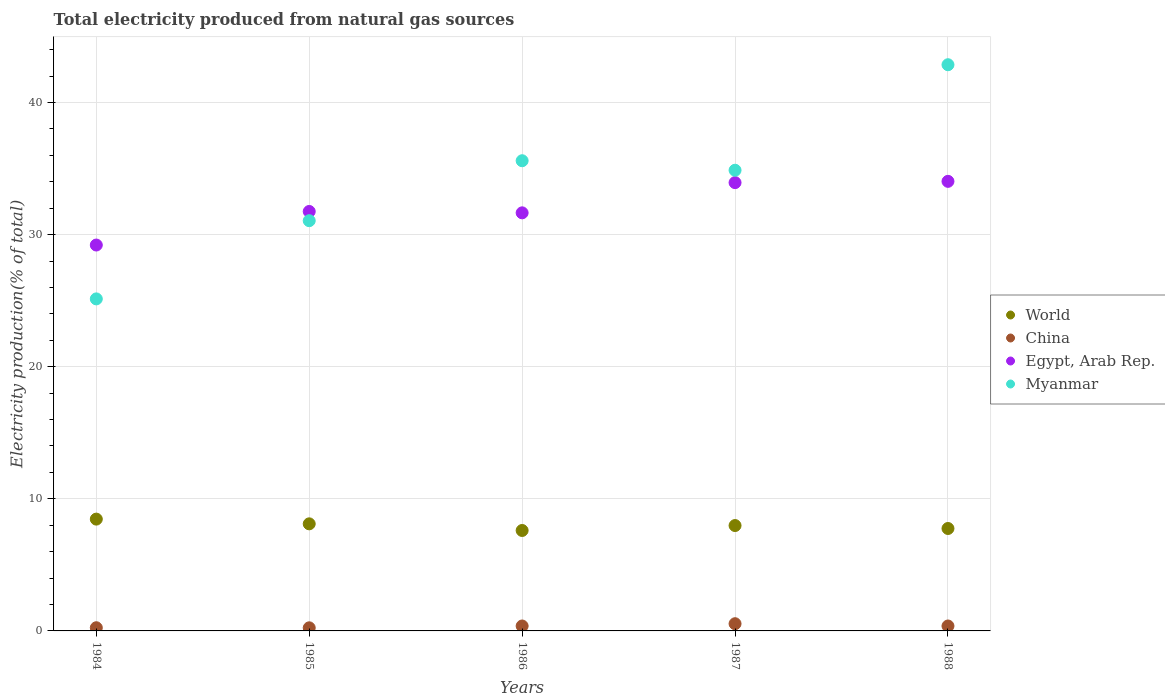How many different coloured dotlines are there?
Provide a succinct answer. 4. Is the number of dotlines equal to the number of legend labels?
Make the answer very short. Yes. What is the total electricity produced in Myanmar in 1986?
Give a very brief answer. 35.59. Across all years, what is the maximum total electricity produced in China?
Provide a succinct answer. 0.55. Across all years, what is the minimum total electricity produced in Myanmar?
Give a very brief answer. 25.13. In which year was the total electricity produced in Egypt, Arab Rep. maximum?
Your answer should be very brief. 1988. In which year was the total electricity produced in China minimum?
Offer a terse response. 1985. What is the total total electricity produced in Myanmar in the graph?
Offer a very short reply. 169.5. What is the difference between the total electricity produced in China in 1984 and that in 1988?
Provide a short and direct response. -0.13. What is the difference between the total electricity produced in Egypt, Arab Rep. in 1985 and the total electricity produced in World in 1987?
Ensure brevity in your answer.  23.77. What is the average total electricity produced in Myanmar per year?
Provide a short and direct response. 33.9. In the year 1985, what is the difference between the total electricity produced in Egypt, Arab Rep. and total electricity produced in China?
Keep it short and to the point. 31.52. What is the ratio of the total electricity produced in China in 1985 to that in 1988?
Give a very brief answer. 0.63. Is the total electricity produced in Myanmar in 1986 less than that in 1987?
Ensure brevity in your answer.  No. Is the difference between the total electricity produced in Egypt, Arab Rep. in 1986 and 1988 greater than the difference between the total electricity produced in China in 1986 and 1988?
Keep it short and to the point. No. What is the difference between the highest and the second highest total electricity produced in World?
Give a very brief answer. 0.36. What is the difference between the highest and the lowest total electricity produced in Myanmar?
Make the answer very short. 17.72. Is it the case that in every year, the sum of the total electricity produced in Myanmar and total electricity produced in World  is greater than the total electricity produced in China?
Your response must be concise. Yes. Is the total electricity produced in World strictly greater than the total electricity produced in China over the years?
Your answer should be compact. Yes. What is the difference between two consecutive major ticks on the Y-axis?
Provide a succinct answer. 10. Are the values on the major ticks of Y-axis written in scientific E-notation?
Your answer should be very brief. No. Does the graph contain grids?
Offer a very short reply. Yes. How many legend labels are there?
Ensure brevity in your answer.  4. What is the title of the graph?
Ensure brevity in your answer.  Total electricity produced from natural gas sources. Does "Central Europe" appear as one of the legend labels in the graph?
Your answer should be very brief. No. What is the label or title of the X-axis?
Ensure brevity in your answer.  Years. What is the Electricity production(% of total) of World in 1984?
Your answer should be compact. 8.46. What is the Electricity production(% of total) of China in 1984?
Keep it short and to the point. 0.24. What is the Electricity production(% of total) of Egypt, Arab Rep. in 1984?
Offer a terse response. 29.21. What is the Electricity production(% of total) in Myanmar in 1984?
Make the answer very short. 25.13. What is the Electricity production(% of total) in World in 1985?
Your answer should be very brief. 8.11. What is the Electricity production(% of total) of China in 1985?
Ensure brevity in your answer.  0.23. What is the Electricity production(% of total) in Egypt, Arab Rep. in 1985?
Give a very brief answer. 31.75. What is the Electricity production(% of total) in Myanmar in 1985?
Offer a very short reply. 31.05. What is the Electricity production(% of total) in World in 1986?
Give a very brief answer. 7.6. What is the Electricity production(% of total) of China in 1986?
Your answer should be compact. 0.37. What is the Electricity production(% of total) in Egypt, Arab Rep. in 1986?
Make the answer very short. 31.65. What is the Electricity production(% of total) in Myanmar in 1986?
Give a very brief answer. 35.59. What is the Electricity production(% of total) in World in 1987?
Offer a terse response. 7.98. What is the Electricity production(% of total) in China in 1987?
Ensure brevity in your answer.  0.55. What is the Electricity production(% of total) of Egypt, Arab Rep. in 1987?
Ensure brevity in your answer.  33.93. What is the Electricity production(% of total) in Myanmar in 1987?
Your answer should be very brief. 34.87. What is the Electricity production(% of total) of World in 1988?
Provide a succinct answer. 7.75. What is the Electricity production(% of total) of China in 1988?
Your answer should be compact. 0.37. What is the Electricity production(% of total) of Egypt, Arab Rep. in 1988?
Keep it short and to the point. 34.03. What is the Electricity production(% of total) of Myanmar in 1988?
Provide a succinct answer. 42.86. Across all years, what is the maximum Electricity production(% of total) in World?
Offer a terse response. 8.46. Across all years, what is the maximum Electricity production(% of total) of China?
Your answer should be very brief. 0.55. Across all years, what is the maximum Electricity production(% of total) of Egypt, Arab Rep.?
Your response must be concise. 34.03. Across all years, what is the maximum Electricity production(% of total) of Myanmar?
Provide a succinct answer. 42.86. Across all years, what is the minimum Electricity production(% of total) of World?
Keep it short and to the point. 7.6. Across all years, what is the minimum Electricity production(% of total) in China?
Give a very brief answer. 0.23. Across all years, what is the minimum Electricity production(% of total) of Egypt, Arab Rep.?
Keep it short and to the point. 29.21. Across all years, what is the minimum Electricity production(% of total) in Myanmar?
Offer a very short reply. 25.13. What is the total Electricity production(% of total) in World in the graph?
Ensure brevity in your answer.  39.9. What is the total Electricity production(% of total) of China in the graph?
Your answer should be very brief. 1.77. What is the total Electricity production(% of total) of Egypt, Arab Rep. in the graph?
Your answer should be very brief. 160.57. What is the total Electricity production(% of total) of Myanmar in the graph?
Offer a very short reply. 169.5. What is the difference between the Electricity production(% of total) of World in 1984 and that in 1985?
Offer a terse response. 0.36. What is the difference between the Electricity production(% of total) in China in 1984 and that in 1985?
Provide a succinct answer. 0.01. What is the difference between the Electricity production(% of total) of Egypt, Arab Rep. in 1984 and that in 1985?
Keep it short and to the point. -2.54. What is the difference between the Electricity production(% of total) in Myanmar in 1984 and that in 1985?
Ensure brevity in your answer.  -5.92. What is the difference between the Electricity production(% of total) of World in 1984 and that in 1986?
Give a very brief answer. 0.86. What is the difference between the Electricity production(% of total) in China in 1984 and that in 1986?
Your answer should be compact. -0.13. What is the difference between the Electricity production(% of total) in Egypt, Arab Rep. in 1984 and that in 1986?
Offer a terse response. -2.44. What is the difference between the Electricity production(% of total) in Myanmar in 1984 and that in 1986?
Make the answer very short. -10.46. What is the difference between the Electricity production(% of total) in World in 1984 and that in 1987?
Offer a terse response. 0.49. What is the difference between the Electricity production(% of total) of China in 1984 and that in 1987?
Provide a succinct answer. -0.3. What is the difference between the Electricity production(% of total) in Egypt, Arab Rep. in 1984 and that in 1987?
Provide a succinct answer. -4.72. What is the difference between the Electricity production(% of total) in Myanmar in 1984 and that in 1987?
Provide a succinct answer. -9.74. What is the difference between the Electricity production(% of total) of World in 1984 and that in 1988?
Ensure brevity in your answer.  0.71. What is the difference between the Electricity production(% of total) of China in 1984 and that in 1988?
Give a very brief answer. -0.13. What is the difference between the Electricity production(% of total) in Egypt, Arab Rep. in 1984 and that in 1988?
Offer a very short reply. -4.82. What is the difference between the Electricity production(% of total) of Myanmar in 1984 and that in 1988?
Keep it short and to the point. -17.72. What is the difference between the Electricity production(% of total) of World in 1985 and that in 1986?
Provide a short and direct response. 0.5. What is the difference between the Electricity production(% of total) of China in 1985 and that in 1986?
Provide a succinct answer. -0.14. What is the difference between the Electricity production(% of total) of Egypt, Arab Rep. in 1985 and that in 1986?
Your response must be concise. 0.1. What is the difference between the Electricity production(% of total) of Myanmar in 1985 and that in 1986?
Offer a terse response. -4.54. What is the difference between the Electricity production(% of total) in World in 1985 and that in 1987?
Ensure brevity in your answer.  0.13. What is the difference between the Electricity production(% of total) in China in 1985 and that in 1987?
Your answer should be compact. -0.31. What is the difference between the Electricity production(% of total) in Egypt, Arab Rep. in 1985 and that in 1987?
Provide a succinct answer. -2.18. What is the difference between the Electricity production(% of total) of Myanmar in 1985 and that in 1987?
Provide a short and direct response. -3.82. What is the difference between the Electricity production(% of total) of World in 1985 and that in 1988?
Ensure brevity in your answer.  0.35. What is the difference between the Electricity production(% of total) of China in 1985 and that in 1988?
Make the answer very short. -0.14. What is the difference between the Electricity production(% of total) of Egypt, Arab Rep. in 1985 and that in 1988?
Your answer should be compact. -2.28. What is the difference between the Electricity production(% of total) in Myanmar in 1985 and that in 1988?
Your answer should be very brief. -11.8. What is the difference between the Electricity production(% of total) in World in 1986 and that in 1987?
Keep it short and to the point. -0.37. What is the difference between the Electricity production(% of total) of China in 1986 and that in 1987?
Keep it short and to the point. -0.17. What is the difference between the Electricity production(% of total) of Egypt, Arab Rep. in 1986 and that in 1987?
Offer a terse response. -2.29. What is the difference between the Electricity production(% of total) in Myanmar in 1986 and that in 1987?
Ensure brevity in your answer.  0.72. What is the difference between the Electricity production(% of total) of World in 1986 and that in 1988?
Make the answer very short. -0.15. What is the difference between the Electricity production(% of total) in Egypt, Arab Rep. in 1986 and that in 1988?
Your answer should be compact. -2.38. What is the difference between the Electricity production(% of total) in Myanmar in 1986 and that in 1988?
Provide a succinct answer. -7.27. What is the difference between the Electricity production(% of total) of World in 1987 and that in 1988?
Offer a very short reply. 0.22. What is the difference between the Electricity production(% of total) in China in 1987 and that in 1988?
Offer a terse response. 0.17. What is the difference between the Electricity production(% of total) of Egypt, Arab Rep. in 1987 and that in 1988?
Your response must be concise. -0.1. What is the difference between the Electricity production(% of total) in Myanmar in 1987 and that in 1988?
Ensure brevity in your answer.  -7.99. What is the difference between the Electricity production(% of total) of World in 1984 and the Electricity production(% of total) of China in 1985?
Ensure brevity in your answer.  8.23. What is the difference between the Electricity production(% of total) of World in 1984 and the Electricity production(% of total) of Egypt, Arab Rep. in 1985?
Provide a short and direct response. -23.29. What is the difference between the Electricity production(% of total) in World in 1984 and the Electricity production(% of total) in Myanmar in 1985?
Give a very brief answer. -22.59. What is the difference between the Electricity production(% of total) of China in 1984 and the Electricity production(% of total) of Egypt, Arab Rep. in 1985?
Make the answer very short. -31.51. What is the difference between the Electricity production(% of total) in China in 1984 and the Electricity production(% of total) in Myanmar in 1985?
Your response must be concise. -30.81. What is the difference between the Electricity production(% of total) in Egypt, Arab Rep. in 1984 and the Electricity production(% of total) in Myanmar in 1985?
Your response must be concise. -1.84. What is the difference between the Electricity production(% of total) of World in 1984 and the Electricity production(% of total) of China in 1986?
Offer a terse response. 8.09. What is the difference between the Electricity production(% of total) of World in 1984 and the Electricity production(% of total) of Egypt, Arab Rep. in 1986?
Keep it short and to the point. -23.18. What is the difference between the Electricity production(% of total) in World in 1984 and the Electricity production(% of total) in Myanmar in 1986?
Make the answer very short. -27.13. What is the difference between the Electricity production(% of total) in China in 1984 and the Electricity production(% of total) in Egypt, Arab Rep. in 1986?
Your answer should be very brief. -31.41. What is the difference between the Electricity production(% of total) of China in 1984 and the Electricity production(% of total) of Myanmar in 1986?
Make the answer very short. -35.35. What is the difference between the Electricity production(% of total) in Egypt, Arab Rep. in 1984 and the Electricity production(% of total) in Myanmar in 1986?
Make the answer very short. -6.38. What is the difference between the Electricity production(% of total) in World in 1984 and the Electricity production(% of total) in China in 1987?
Your answer should be compact. 7.92. What is the difference between the Electricity production(% of total) of World in 1984 and the Electricity production(% of total) of Egypt, Arab Rep. in 1987?
Your answer should be compact. -25.47. What is the difference between the Electricity production(% of total) of World in 1984 and the Electricity production(% of total) of Myanmar in 1987?
Keep it short and to the point. -26.41. What is the difference between the Electricity production(% of total) in China in 1984 and the Electricity production(% of total) in Egypt, Arab Rep. in 1987?
Make the answer very short. -33.69. What is the difference between the Electricity production(% of total) in China in 1984 and the Electricity production(% of total) in Myanmar in 1987?
Give a very brief answer. -34.63. What is the difference between the Electricity production(% of total) in Egypt, Arab Rep. in 1984 and the Electricity production(% of total) in Myanmar in 1987?
Your response must be concise. -5.66. What is the difference between the Electricity production(% of total) of World in 1984 and the Electricity production(% of total) of China in 1988?
Your response must be concise. 8.09. What is the difference between the Electricity production(% of total) of World in 1984 and the Electricity production(% of total) of Egypt, Arab Rep. in 1988?
Provide a succinct answer. -25.57. What is the difference between the Electricity production(% of total) in World in 1984 and the Electricity production(% of total) in Myanmar in 1988?
Give a very brief answer. -34.39. What is the difference between the Electricity production(% of total) in China in 1984 and the Electricity production(% of total) in Egypt, Arab Rep. in 1988?
Give a very brief answer. -33.79. What is the difference between the Electricity production(% of total) of China in 1984 and the Electricity production(% of total) of Myanmar in 1988?
Keep it short and to the point. -42.62. What is the difference between the Electricity production(% of total) in Egypt, Arab Rep. in 1984 and the Electricity production(% of total) in Myanmar in 1988?
Your response must be concise. -13.65. What is the difference between the Electricity production(% of total) in World in 1985 and the Electricity production(% of total) in China in 1986?
Offer a very short reply. 7.73. What is the difference between the Electricity production(% of total) of World in 1985 and the Electricity production(% of total) of Egypt, Arab Rep. in 1986?
Provide a succinct answer. -23.54. What is the difference between the Electricity production(% of total) in World in 1985 and the Electricity production(% of total) in Myanmar in 1986?
Provide a short and direct response. -27.48. What is the difference between the Electricity production(% of total) in China in 1985 and the Electricity production(% of total) in Egypt, Arab Rep. in 1986?
Your answer should be very brief. -31.41. What is the difference between the Electricity production(% of total) of China in 1985 and the Electricity production(% of total) of Myanmar in 1986?
Provide a short and direct response. -35.36. What is the difference between the Electricity production(% of total) in Egypt, Arab Rep. in 1985 and the Electricity production(% of total) in Myanmar in 1986?
Keep it short and to the point. -3.84. What is the difference between the Electricity production(% of total) of World in 1985 and the Electricity production(% of total) of China in 1987?
Offer a terse response. 7.56. What is the difference between the Electricity production(% of total) in World in 1985 and the Electricity production(% of total) in Egypt, Arab Rep. in 1987?
Your answer should be very brief. -25.83. What is the difference between the Electricity production(% of total) in World in 1985 and the Electricity production(% of total) in Myanmar in 1987?
Your answer should be compact. -26.77. What is the difference between the Electricity production(% of total) of China in 1985 and the Electricity production(% of total) of Egypt, Arab Rep. in 1987?
Offer a terse response. -33.7. What is the difference between the Electricity production(% of total) in China in 1985 and the Electricity production(% of total) in Myanmar in 1987?
Make the answer very short. -34.64. What is the difference between the Electricity production(% of total) of Egypt, Arab Rep. in 1985 and the Electricity production(% of total) of Myanmar in 1987?
Your response must be concise. -3.12. What is the difference between the Electricity production(% of total) in World in 1985 and the Electricity production(% of total) in China in 1988?
Your response must be concise. 7.73. What is the difference between the Electricity production(% of total) in World in 1985 and the Electricity production(% of total) in Egypt, Arab Rep. in 1988?
Keep it short and to the point. -25.92. What is the difference between the Electricity production(% of total) of World in 1985 and the Electricity production(% of total) of Myanmar in 1988?
Your answer should be very brief. -34.75. What is the difference between the Electricity production(% of total) in China in 1985 and the Electricity production(% of total) in Egypt, Arab Rep. in 1988?
Your answer should be compact. -33.8. What is the difference between the Electricity production(% of total) in China in 1985 and the Electricity production(% of total) in Myanmar in 1988?
Provide a short and direct response. -42.62. What is the difference between the Electricity production(% of total) of Egypt, Arab Rep. in 1985 and the Electricity production(% of total) of Myanmar in 1988?
Offer a terse response. -11.11. What is the difference between the Electricity production(% of total) in World in 1986 and the Electricity production(% of total) in China in 1987?
Your answer should be compact. 7.06. What is the difference between the Electricity production(% of total) of World in 1986 and the Electricity production(% of total) of Egypt, Arab Rep. in 1987?
Your answer should be very brief. -26.33. What is the difference between the Electricity production(% of total) of World in 1986 and the Electricity production(% of total) of Myanmar in 1987?
Ensure brevity in your answer.  -27.27. What is the difference between the Electricity production(% of total) of China in 1986 and the Electricity production(% of total) of Egypt, Arab Rep. in 1987?
Ensure brevity in your answer.  -33.56. What is the difference between the Electricity production(% of total) in China in 1986 and the Electricity production(% of total) in Myanmar in 1987?
Offer a terse response. -34.5. What is the difference between the Electricity production(% of total) in Egypt, Arab Rep. in 1986 and the Electricity production(% of total) in Myanmar in 1987?
Your response must be concise. -3.22. What is the difference between the Electricity production(% of total) of World in 1986 and the Electricity production(% of total) of China in 1988?
Ensure brevity in your answer.  7.23. What is the difference between the Electricity production(% of total) in World in 1986 and the Electricity production(% of total) in Egypt, Arab Rep. in 1988?
Keep it short and to the point. -26.43. What is the difference between the Electricity production(% of total) of World in 1986 and the Electricity production(% of total) of Myanmar in 1988?
Your answer should be compact. -35.25. What is the difference between the Electricity production(% of total) of China in 1986 and the Electricity production(% of total) of Egypt, Arab Rep. in 1988?
Offer a terse response. -33.66. What is the difference between the Electricity production(% of total) in China in 1986 and the Electricity production(% of total) in Myanmar in 1988?
Give a very brief answer. -42.48. What is the difference between the Electricity production(% of total) of Egypt, Arab Rep. in 1986 and the Electricity production(% of total) of Myanmar in 1988?
Provide a short and direct response. -11.21. What is the difference between the Electricity production(% of total) of World in 1987 and the Electricity production(% of total) of China in 1988?
Offer a very short reply. 7.6. What is the difference between the Electricity production(% of total) of World in 1987 and the Electricity production(% of total) of Egypt, Arab Rep. in 1988?
Provide a short and direct response. -26.05. What is the difference between the Electricity production(% of total) of World in 1987 and the Electricity production(% of total) of Myanmar in 1988?
Your answer should be compact. -34.88. What is the difference between the Electricity production(% of total) of China in 1987 and the Electricity production(% of total) of Egypt, Arab Rep. in 1988?
Provide a succinct answer. -33.48. What is the difference between the Electricity production(% of total) of China in 1987 and the Electricity production(% of total) of Myanmar in 1988?
Offer a very short reply. -42.31. What is the difference between the Electricity production(% of total) in Egypt, Arab Rep. in 1987 and the Electricity production(% of total) in Myanmar in 1988?
Provide a short and direct response. -8.92. What is the average Electricity production(% of total) of World per year?
Ensure brevity in your answer.  7.98. What is the average Electricity production(% of total) in China per year?
Offer a terse response. 0.35. What is the average Electricity production(% of total) of Egypt, Arab Rep. per year?
Give a very brief answer. 32.11. What is the average Electricity production(% of total) in Myanmar per year?
Your answer should be compact. 33.9. In the year 1984, what is the difference between the Electricity production(% of total) in World and Electricity production(% of total) in China?
Your answer should be compact. 8.22. In the year 1984, what is the difference between the Electricity production(% of total) of World and Electricity production(% of total) of Egypt, Arab Rep.?
Offer a terse response. -20.75. In the year 1984, what is the difference between the Electricity production(% of total) in World and Electricity production(% of total) in Myanmar?
Provide a short and direct response. -16.67. In the year 1984, what is the difference between the Electricity production(% of total) of China and Electricity production(% of total) of Egypt, Arab Rep.?
Offer a terse response. -28.97. In the year 1984, what is the difference between the Electricity production(% of total) in China and Electricity production(% of total) in Myanmar?
Provide a short and direct response. -24.89. In the year 1984, what is the difference between the Electricity production(% of total) of Egypt, Arab Rep. and Electricity production(% of total) of Myanmar?
Your response must be concise. 4.08. In the year 1985, what is the difference between the Electricity production(% of total) in World and Electricity production(% of total) in China?
Your response must be concise. 7.87. In the year 1985, what is the difference between the Electricity production(% of total) of World and Electricity production(% of total) of Egypt, Arab Rep.?
Ensure brevity in your answer.  -23.64. In the year 1985, what is the difference between the Electricity production(% of total) in World and Electricity production(% of total) in Myanmar?
Your response must be concise. -22.95. In the year 1985, what is the difference between the Electricity production(% of total) in China and Electricity production(% of total) in Egypt, Arab Rep.?
Ensure brevity in your answer.  -31.52. In the year 1985, what is the difference between the Electricity production(% of total) of China and Electricity production(% of total) of Myanmar?
Offer a very short reply. -30.82. In the year 1985, what is the difference between the Electricity production(% of total) in Egypt, Arab Rep. and Electricity production(% of total) in Myanmar?
Provide a short and direct response. 0.7. In the year 1986, what is the difference between the Electricity production(% of total) of World and Electricity production(% of total) of China?
Your answer should be compact. 7.23. In the year 1986, what is the difference between the Electricity production(% of total) of World and Electricity production(% of total) of Egypt, Arab Rep.?
Give a very brief answer. -24.04. In the year 1986, what is the difference between the Electricity production(% of total) of World and Electricity production(% of total) of Myanmar?
Ensure brevity in your answer.  -27.99. In the year 1986, what is the difference between the Electricity production(% of total) of China and Electricity production(% of total) of Egypt, Arab Rep.?
Your response must be concise. -31.27. In the year 1986, what is the difference between the Electricity production(% of total) in China and Electricity production(% of total) in Myanmar?
Keep it short and to the point. -35.22. In the year 1986, what is the difference between the Electricity production(% of total) of Egypt, Arab Rep. and Electricity production(% of total) of Myanmar?
Provide a short and direct response. -3.94. In the year 1987, what is the difference between the Electricity production(% of total) of World and Electricity production(% of total) of China?
Give a very brief answer. 7.43. In the year 1987, what is the difference between the Electricity production(% of total) in World and Electricity production(% of total) in Egypt, Arab Rep.?
Keep it short and to the point. -25.96. In the year 1987, what is the difference between the Electricity production(% of total) in World and Electricity production(% of total) in Myanmar?
Give a very brief answer. -26.89. In the year 1987, what is the difference between the Electricity production(% of total) of China and Electricity production(% of total) of Egypt, Arab Rep.?
Ensure brevity in your answer.  -33.39. In the year 1987, what is the difference between the Electricity production(% of total) in China and Electricity production(% of total) in Myanmar?
Your answer should be very brief. -34.33. In the year 1987, what is the difference between the Electricity production(% of total) of Egypt, Arab Rep. and Electricity production(% of total) of Myanmar?
Make the answer very short. -0.94. In the year 1988, what is the difference between the Electricity production(% of total) of World and Electricity production(% of total) of China?
Keep it short and to the point. 7.38. In the year 1988, what is the difference between the Electricity production(% of total) of World and Electricity production(% of total) of Egypt, Arab Rep.?
Your answer should be very brief. -26.28. In the year 1988, what is the difference between the Electricity production(% of total) of World and Electricity production(% of total) of Myanmar?
Make the answer very short. -35.1. In the year 1988, what is the difference between the Electricity production(% of total) in China and Electricity production(% of total) in Egypt, Arab Rep.?
Make the answer very short. -33.66. In the year 1988, what is the difference between the Electricity production(% of total) of China and Electricity production(% of total) of Myanmar?
Provide a succinct answer. -42.48. In the year 1988, what is the difference between the Electricity production(% of total) of Egypt, Arab Rep. and Electricity production(% of total) of Myanmar?
Keep it short and to the point. -8.83. What is the ratio of the Electricity production(% of total) of World in 1984 to that in 1985?
Offer a very short reply. 1.04. What is the ratio of the Electricity production(% of total) in China in 1984 to that in 1985?
Provide a succinct answer. 1.03. What is the ratio of the Electricity production(% of total) of Myanmar in 1984 to that in 1985?
Give a very brief answer. 0.81. What is the ratio of the Electricity production(% of total) in World in 1984 to that in 1986?
Provide a short and direct response. 1.11. What is the ratio of the Electricity production(% of total) in China in 1984 to that in 1986?
Offer a very short reply. 0.65. What is the ratio of the Electricity production(% of total) of Egypt, Arab Rep. in 1984 to that in 1986?
Your answer should be very brief. 0.92. What is the ratio of the Electricity production(% of total) of Myanmar in 1984 to that in 1986?
Your answer should be compact. 0.71. What is the ratio of the Electricity production(% of total) in World in 1984 to that in 1987?
Keep it short and to the point. 1.06. What is the ratio of the Electricity production(% of total) in China in 1984 to that in 1987?
Your response must be concise. 0.44. What is the ratio of the Electricity production(% of total) of Egypt, Arab Rep. in 1984 to that in 1987?
Offer a very short reply. 0.86. What is the ratio of the Electricity production(% of total) in Myanmar in 1984 to that in 1987?
Provide a succinct answer. 0.72. What is the ratio of the Electricity production(% of total) in World in 1984 to that in 1988?
Your response must be concise. 1.09. What is the ratio of the Electricity production(% of total) of China in 1984 to that in 1988?
Offer a very short reply. 0.65. What is the ratio of the Electricity production(% of total) in Egypt, Arab Rep. in 1984 to that in 1988?
Give a very brief answer. 0.86. What is the ratio of the Electricity production(% of total) in Myanmar in 1984 to that in 1988?
Give a very brief answer. 0.59. What is the ratio of the Electricity production(% of total) of World in 1985 to that in 1986?
Make the answer very short. 1.07. What is the ratio of the Electricity production(% of total) of China in 1985 to that in 1986?
Make the answer very short. 0.63. What is the ratio of the Electricity production(% of total) in Myanmar in 1985 to that in 1986?
Make the answer very short. 0.87. What is the ratio of the Electricity production(% of total) in World in 1985 to that in 1987?
Your response must be concise. 1.02. What is the ratio of the Electricity production(% of total) of China in 1985 to that in 1987?
Provide a short and direct response. 0.43. What is the ratio of the Electricity production(% of total) of Egypt, Arab Rep. in 1985 to that in 1987?
Offer a terse response. 0.94. What is the ratio of the Electricity production(% of total) in Myanmar in 1985 to that in 1987?
Provide a short and direct response. 0.89. What is the ratio of the Electricity production(% of total) in World in 1985 to that in 1988?
Provide a succinct answer. 1.05. What is the ratio of the Electricity production(% of total) of China in 1985 to that in 1988?
Give a very brief answer. 0.63. What is the ratio of the Electricity production(% of total) in Egypt, Arab Rep. in 1985 to that in 1988?
Your response must be concise. 0.93. What is the ratio of the Electricity production(% of total) of Myanmar in 1985 to that in 1988?
Your response must be concise. 0.72. What is the ratio of the Electricity production(% of total) of World in 1986 to that in 1987?
Give a very brief answer. 0.95. What is the ratio of the Electricity production(% of total) in China in 1986 to that in 1987?
Your answer should be very brief. 0.68. What is the ratio of the Electricity production(% of total) in Egypt, Arab Rep. in 1986 to that in 1987?
Offer a very short reply. 0.93. What is the ratio of the Electricity production(% of total) of Myanmar in 1986 to that in 1987?
Your answer should be very brief. 1.02. What is the ratio of the Electricity production(% of total) in World in 1986 to that in 1988?
Keep it short and to the point. 0.98. What is the ratio of the Electricity production(% of total) in Egypt, Arab Rep. in 1986 to that in 1988?
Make the answer very short. 0.93. What is the ratio of the Electricity production(% of total) of Myanmar in 1986 to that in 1988?
Give a very brief answer. 0.83. What is the ratio of the Electricity production(% of total) of World in 1987 to that in 1988?
Offer a terse response. 1.03. What is the ratio of the Electricity production(% of total) in China in 1987 to that in 1988?
Offer a very short reply. 1.46. What is the ratio of the Electricity production(% of total) of Egypt, Arab Rep. in 1987 to that in 1988?
Ensure brevity in your answer.  1. What is the ratio of the Electricity production(% of total) of Myanmar in 1987 to that in 1988?
Keep it short and to the point. 0.81. What is the difference between the highest and the second highest Electricity production(% of total) of World?
Offer a very short reply. 0.36. What is the difference between the highest and the second highest Electricity production(% of total) of China?
Offer a very short reply. 0.17. What is the difference between the highest and the second highest Electricity production(% of total) in Egypt, Arab Rep.?
Your answer should be compact. 0.1. What is the difference between the highest and the second highest Electricity production(% of total) of Myanmar?
Your answer should be compact. 7.27. What is the difference between the highest and the lowest Electricity production(% of total) in World?
Offer a terse response. 0.86. What is the difference between the highest and the lowest Electricity production(% of total) in China?
Make the answer very short. 0.31. What is the difference between the highest and the lowest Electricity production(% of total) of Egypt, Arab Rep.?
Offer a terse response. 4.82. What is the difference between the highest and the lowest Electricity production(% of total) of Myanmar?
Provide a succinct answer. 17.72. 